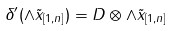<formula> <loc_0><loc_0><loc_500><loc_500>\delta ^ { \prime } ( \wedge \tilde { x } _ { [ 1 , n ] } ) = D \otimes \wedge \tilde { x } _ { [ 1 , n ] }</formula> 